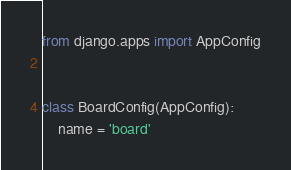<code> <loc_0><loc_0><loc_500><loc_500><_Python_>from django.apps import AppConfig


class BoardConfig(AppConfig):
    name = 'board'</code> 